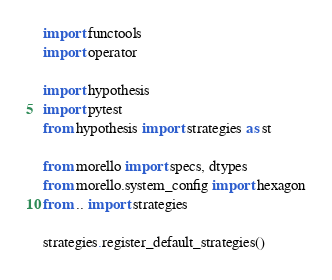<code> <loc_0><loc_0><loc_500><loc_500><_Python_>import functools
import operator

import hypothesis
import pytest
from hypothesis import strategies as st

from morello import specs, dtypes
from morello.system_config import hexagon
from .. import strategies

strategies.register_default_strategies()

</code> 